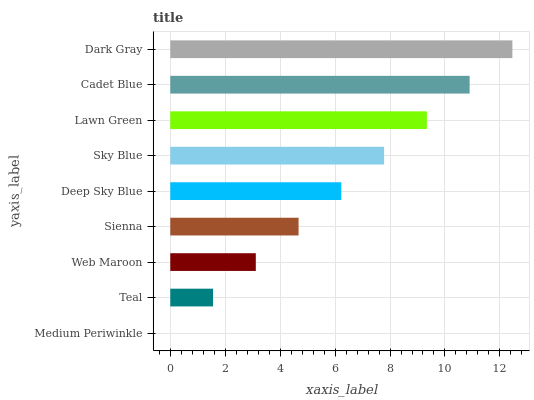Is Medium Periwinkle the minimum?
Answer yes or no. Yes. Is Dark Gray the maximum?
Answer yes or no. Yes. Is Teal the minimum?
Answer yes or no. No. Is Teal the maximum?
Answer yes or no. No. Is Teal greater than Medium Periwinkle?
Answer yes or no. Yes. Is Medium Periwinkle less than Teal?
Answer yes or no. Yes. Is Medium Periwinkle greater than Teal?
Answer yes or no. No. Is Teal less than Medium Periwinkle?
Answer yes or no. No. Is Deep Sky Blue the high median?
Answer yes or no. Yes. Is Deep Sky Blue the low median?
Answer yes or no. Yes. Is Sienna the high median?
Answer yes or no. No. Is Web Maroon the low median?
Answer yes or no. No. 